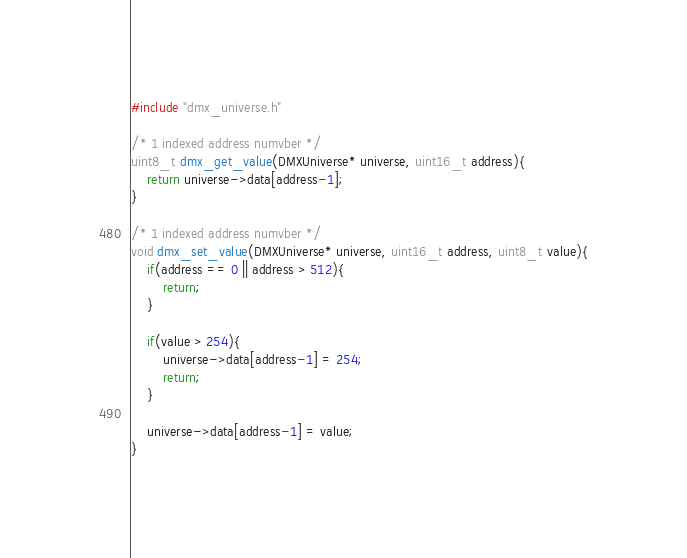Convert code to text. <code><loc_0><loc_0><loc_500><loc_500><_C_>#include "dmx_universe.h"

/* 1 indexed address numvber */
uint8_t dmx_get_value(DMXUniverse* universe, uint16_t address){
    return universe->data[address-1];
}

/* 1 indexed address numvber */
void dmx_set_value(DMXUniverse* universe, uint16_t address, uint8_t value){
    if(address == 0 || address > 512){
        return;
    }

    if(value > 254){
        universe->data[address-1] = 254;
        return;
    }

    universe->data[address-1] = value;
}
</code> 